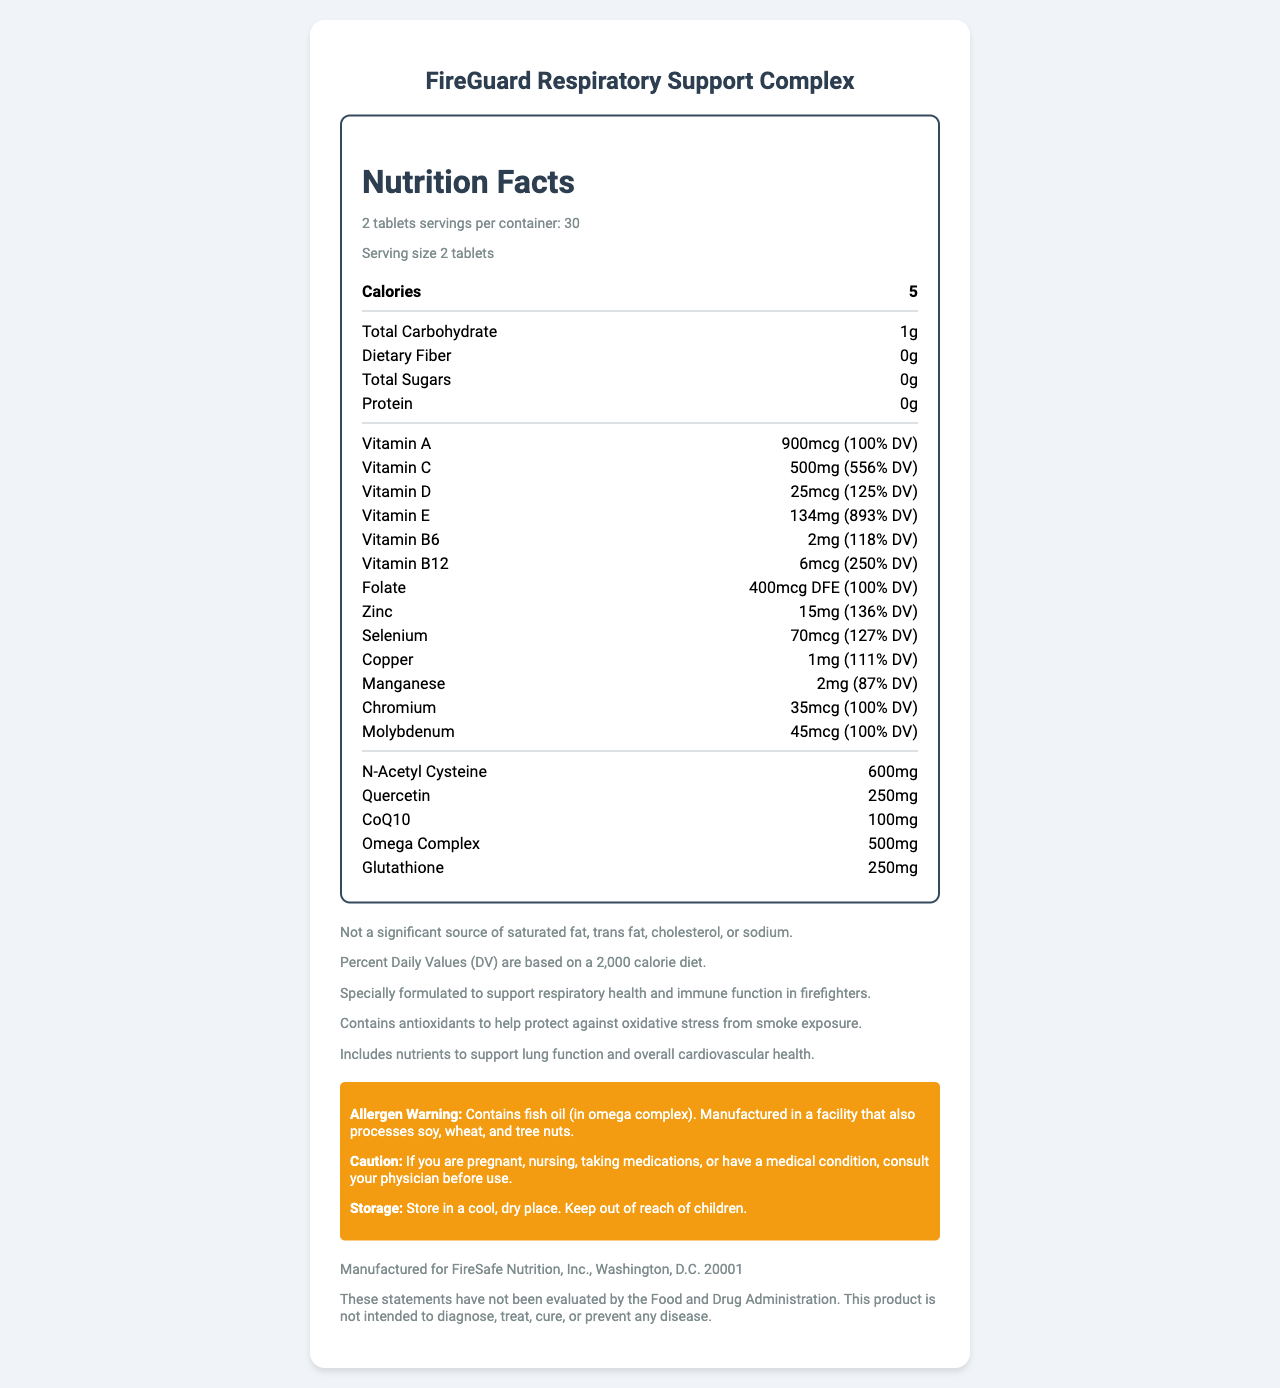what is the serving size of FireGuard Respiratory Support Complex? The serving size is indicated as "2 tablets" in the serving information section.
Answer: 2 tablets how many servings are contained in one package? The document states "Servings Per Container: 30".
Answer: 30 how many calories are in a single serving? The Calories per Serving are listed as "5".
Answer: 5 what is the amount of Vitamin C per serving? The amount of Vitamin C per serving is mentioned as "500mg (556% DV)".
Answer: 500mg (556% DV) what allergen does FireGuard Respiratory Support Complex contain? The allergen warning specifies that it contains fish oil.
Answer: Fish oil (in omega complex) how much N-Acetyl Cysteine is in each serving? A. 250mg B. 500mg C. 600mg The document indicates 600mg of N-Acetyl Cysteine per serving.
Answer: C which vitamin has the highest % Daily Value in this supplement? A. Vitamin A B. Vitamin C C. Vitamin E D. Vitamin B12 Vitamin E has 893% DV, which is the highest among the listed vitamins.
Answer: C is this supplement a significant source of dietary fiber? The document states "Dietary Fiber: 0g" and also mentions that it's not a significant source of dietary fiber.
Answer: No does the supplement include any ingredient to support cardiovascular health? The supplement includes nutrients "to support lung function and overall cardiovascular health."
Answer: Yes summarize the purpose of FireGuard Respiratory Support Complex. The description highlights the supplement's focus on respiratory and immune support for firefighters, detailing its components and benefits for lung and cardiovascular health.
Answer: FireGuard Respiratory Support Complex is designed to support respiratory health and immune function in firefighters. It includes vitamins, minerals, antioxidants, and other nutrients to protect against oxidative stress from smoke exposure, support lung function, and overall cardiovascular health. It comes in 2 tablets per serving with a total of 30 servings per container. how is this product manufactured? The document only mentions it is "manufactured for FireSafe Nutrition, Inc." but doesn't provide specific manufacturing process details.
Answer: Not enough information 